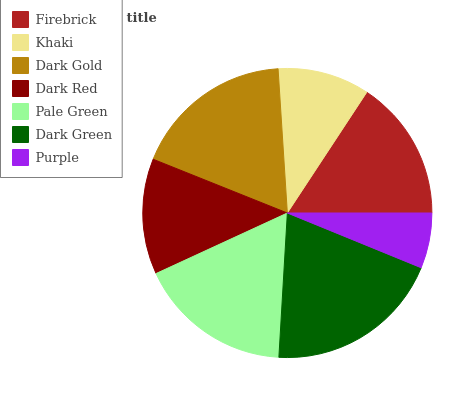Is Purple the minimum?
Answer yes or no. Yes. Is Dark Green the maximum?
Answer yes or no. Yes. Is Khaki the minimum?
Answer yes or no. No. Is Khaki the maximum?
Answer yes or no. No. Is Firebrick greater than Khaki?
Answer yes or no. Yes. Is Khaki less than Firebrick?
Answer yes or no. Yes. Is Khaki greater than Firebrick?
Answer yes or no. No. Is Firebrick less than Khaki?
Answer yes or no. No. Is Firebrick the high median?
Answer yes or no. Yes. Is Firebrick the low median?
Answer yes or no. Yes. Is Khaki the high median?
Answer yes or no. No. Is Dark Gold the low median?
Answer yes or no. No. 